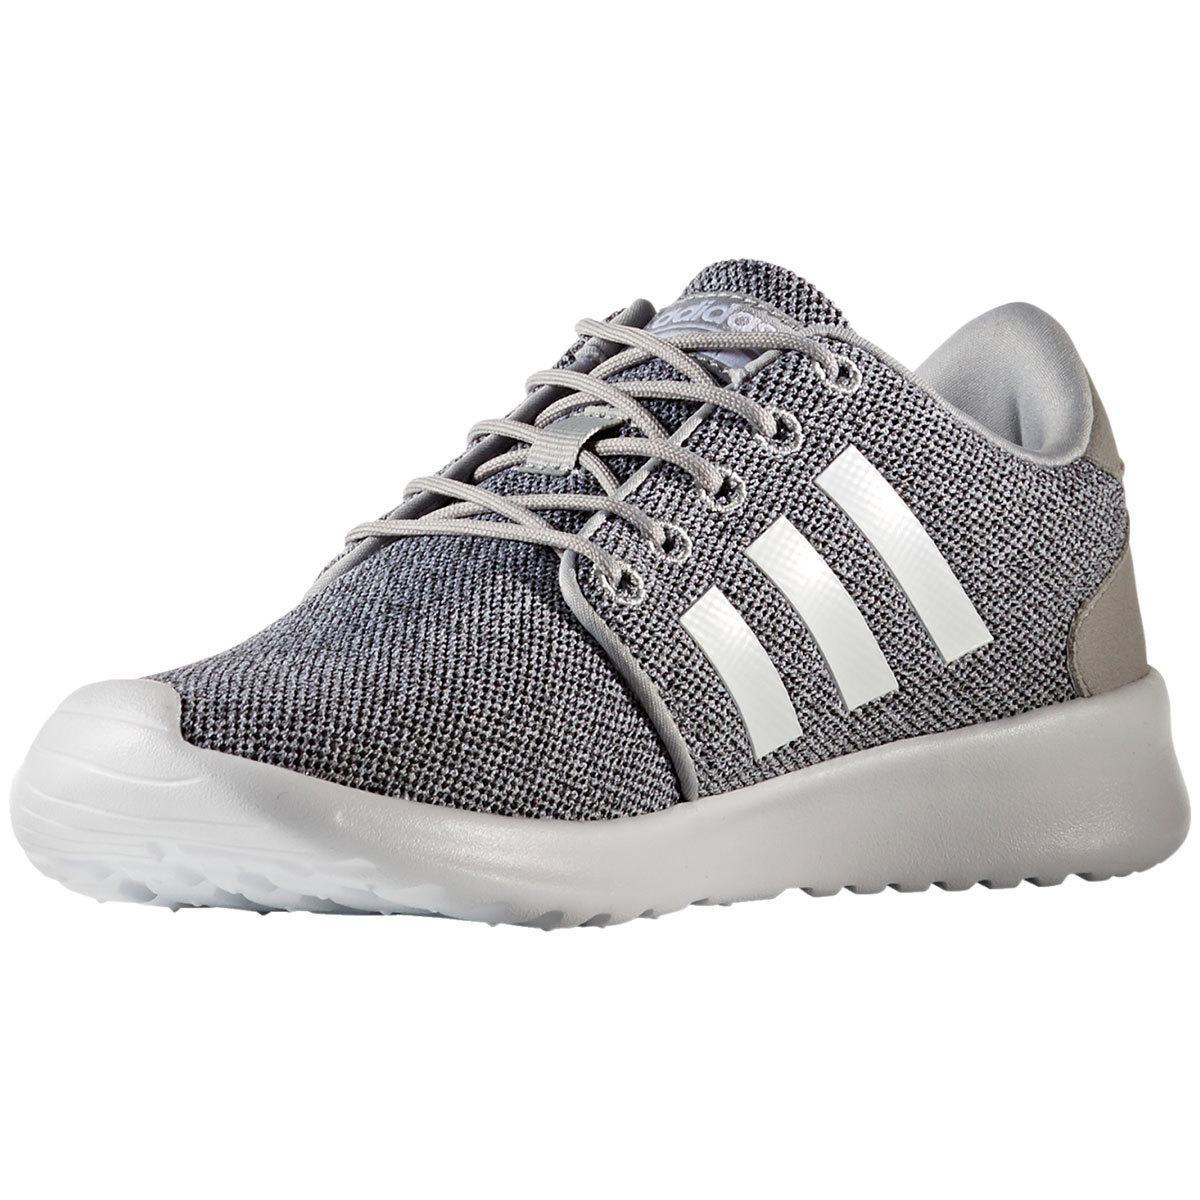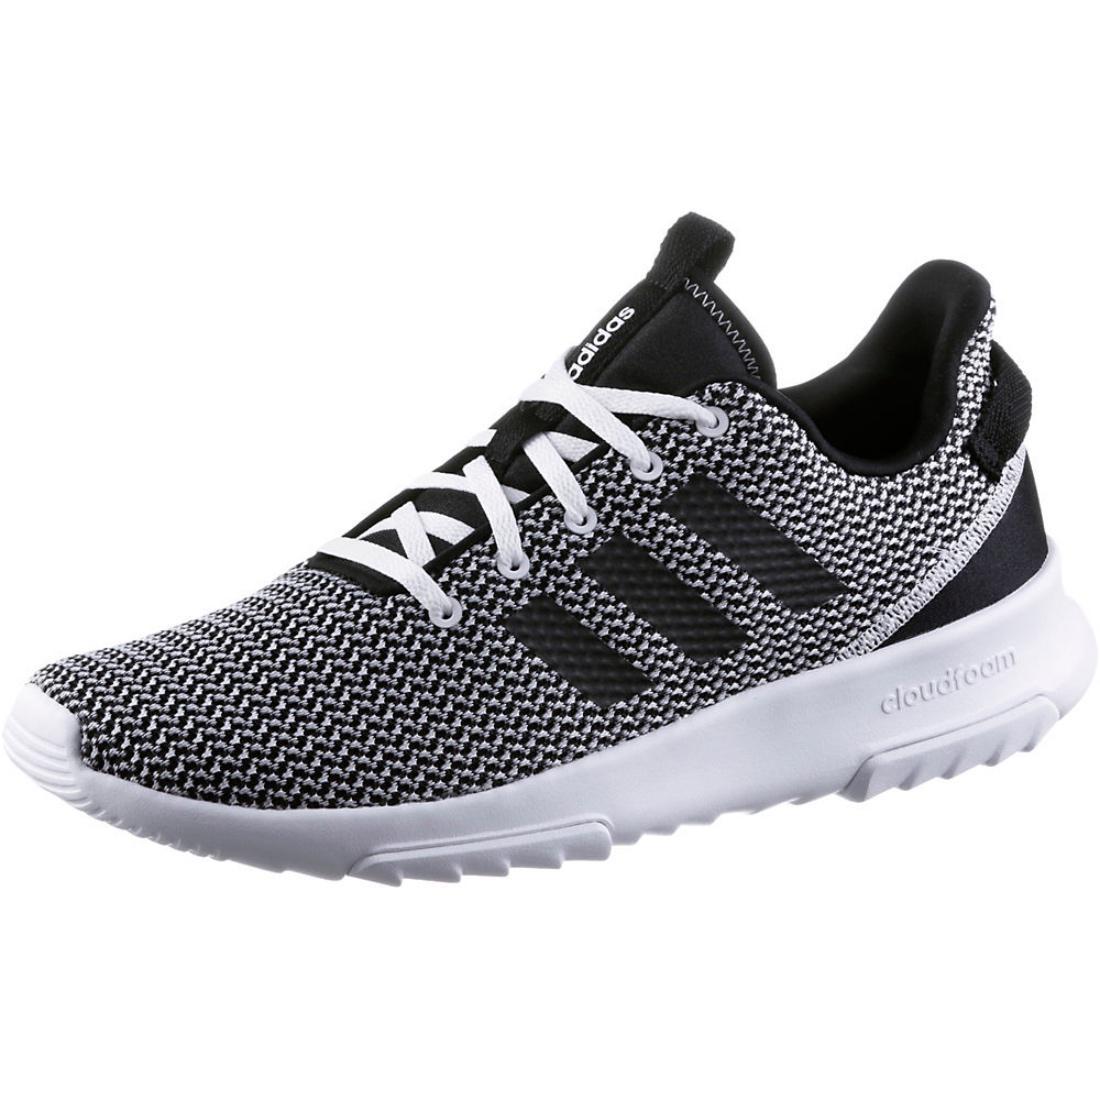The first image is the image on the left, the second image is the image on the right. Analyze the images presented: Is the assertion "One shoe has stripes on the side that are white, and the other one has stripes on the side that are a darker color." valid? Answer yes or no. Yes. The first image is the image on the left, the second image is the image on the right. Examine the images to the left and right. Is the description "Both shoes have three white stripes on the side of them." accurate? Answer yes or no. No. 